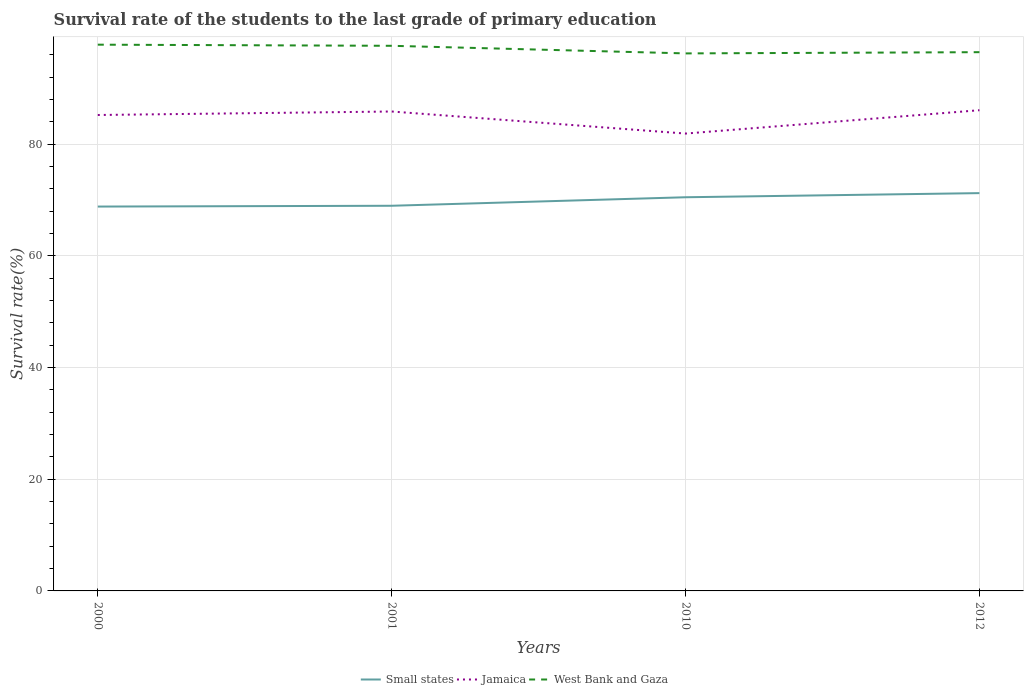Does the line corresponding to Jamaica intersect with the line corresponding to West Bank and Gaza?
Provide a short and direct response. No. Across all years, what is the maximum survival rate of the students in Jamaica?
Your answer should be very brief. 81.9. In which year was the survival rate of the students in West Bank and Gaza maximum?
Your answer should be compact. 2010. What is the total survival rate of the students in Small states in the graph?
Ensure brevity in your answer.  -2.41. What is the difference between the highest and the second highest survival rate of the students in Small states?
Provide a short and direct response. 2.41. Is the survival rate of the students in Small states strictly greater than the survival rate of the students in West Bank and Gaza over the years?
Provide a short and direct response. Yes. How many years are there in the graph?
Provide a short and direct response. 4. Does the graph contain any zero values?
Your response must be concise. No. Does the graph contain grids?
Give a very brief answer. Yes. Where does the legend appear in the graph?
Your answer should be very brief. Bottom center. How are the legend labels stacked?
Your answer should be very brief. Horizontal. What is the title of the graph?
Offer a terse response. Survival rate of the students to the last grade of primary education. What is the label or title of the X-axis?
Provide a short and direct response. Years. What is the label or title of the Y-axis?
Provide a succinct answer. Survival rate(%). What is the Survival rate(%) in Small states in 2000?
Your answer should be compact. 68.83. What is the Survival rate(%) in Jamaica in 2000?
Offer a terse response. 85.22. What is the Survival rate(%) in West Bank and Gaza in 2000?
Your answer should be compact. 97.82. What is the Survival rate(%) in Small states in 2001?
Make the answer very short. 68.97. What is the Survival rate(%) of Jamaica in 2001?
Offer a very short reply. 85.85. What is the Survival rate(%) of West Bank and Gaza in 2001?
Ensure brevity in your answer.  97.61. What is the Survival rate(%) of Small states in 2010?
Your response must be concise. 70.49. What is the Survival rate(%) in Jamaica in 2010?
Provide a succinct answer. 81.9. What is the Survival rate(%) of West Bank and Gaza in 2010?
Give a very brief answer. 96.25. What is the Survival rate(%) of Small states in 2012?
Your answer should be very brief. 71.23. What is the Survival rate(%) of Jamaica in 2012?
Provide a short and direct response. 86.08. What is the Survival rate(%) in West Bank and Gaza in 2012?
Make the answer very short. 96.47. Across all years, what is the maximum Survival rate(%) of Small states?
Ensure brevity in your answer.  71.23. Across all years, what is the maximum Survival rate(%) of Jamaica?
Keep it short and to the point. 86.08. Across all years, what is the maximum Survival rate(%) in West Bank and Gaza?
Your answer should be compact. 97.82. Across all years, what is the minimum Survival rate(%) in Small states?
Your response must be concise. 68.83. Across all years, what is the minimum Survival rate(%) in Jamaica?
Make the answer very short. 81.9. Across all years, what is the minimum Survival rate(%) of West Bank and Gaza?
Ensure brevity in your answer.  96.25. What is the total Survival rate(%) of Small states in the graph?
Offer a very short reply. 279.52. What is the total Survival rate(%) in Jamaica in the graph?
Provide a short and direct response. 339.05. What is the total Survival rate(%) in West Bank and Gaza in the graph?
Ensure brevity in your answer.  388.16. What is the difference between the Survival rate(%) of Small states in 2000 and that in 2001?
Offer a very short reply. -0.14. What is the difference between the Survival rate(%) in Jamaica in 2000 and that in 2001?
Your answer should be very brief. -0.63. What is the difference between the Survival rate(%) of West Bank and Gaza in 2000 and that in 2001?
Offer a terse response. 0.2. What is the difference between the Survival rate(%) of Small states in 2000 and that in 2010?
Provide a succinct answer. -1.67. What is the difference between the Survival rate(%) in Jamaica in 2000 and that in 2010?
Make the answer very short. 3.32. What is the difference between the Survival rate(%) in West Bank and Gaza in 2000 and that in 2010?
Your answer should be compact. 1.56. What is the difference between the Survival rate(%) in Small states in 2000 and that in 2012?
Offer a terse response. -2.41. What is the difference between the Survival rate(%) of Jamaica in 2000 and that in 2012?
Make the answer very short. -0.86. What is the difference between the Survival rate(%) in West Bank and Gaza in 2000 and that in 2012?
Your answer should be very brief. 1.34. What is the difference between the Survival rate(%) of Small states in 2001 and that in 2010?
Offer a terse response. -1.52. What is the difference between the Survival rate(%) of Jamaica in 2001 and that in 2010?
Ensure brevity in your answer.  3.95. What is the difference between the Survival rate(%) in West Bank and Gaza in 2001 and that in 2010?
Provide a short and direct response. 1.36. What is the difference between the Survival rate(%) in Small states in 2001 and that in 2012?
Your response must be concise. -2.26. What is the difference between the Survival rate(%) in Jamaica in 2001 and that in 2012?
Provide a succinct answer. -0.23. What is the difference between the Survival rate(%) in West Bank and Gaza in 2001 and that in 2012?
Give a very brief answer. 1.14. What is the difference between the Survival rate(%) in Small states in 2010 and that in 2012?
Ensure brevity in your answer.  -0.74. What is the difference between the Survival rate(%) of Jamaica in 2010 and that in 2012?
Offer a terse response. -4.18. What is the difference between the Survival rate(%) of West Bank and Gaza in 2010 and that in 2012?
Your answer should be compact. -0.22. What is the difference between the Survival rate(%) in Small states in 2000 and the Survival rate(%) in Jamaica in 2001?
Provide a succinct answer. -17.02. What is the difference between the Survival rate(%) of Small states in 2000 and the Survival rate(%) of West Bank and Gaza in 2001?
Give a very brief answer. -28.79. What is the difference between the Survival rate(%) in Jamaica in 2000 and the Survival rate(%) in West Bank and Gaza in 2001?
Offer a very short reply. -12.39. What is the difference between the Survival rate(%) in Small states in 2000 and the Survival rate(%) in Jamaica in 2010?
Provide a short and direct response. -13.07. What is the difference between the Survival rate(%) in Small states in 2000 and the Survival rate(%) in West Bank and Gaza in 2010?
Your response must be concise. -27.43. What is the difference between the Survival rate(%) of Jamaica in 2000 and the Survival rate(%) of West Bank and Gaza in 2010?
Provide a succinct answer. -11.03. What is the difference between the Survival rate(%) of Small states in 2000 and the Survival rate(%) of Jamaica in 2012?
Provide a succinct answer. -17.25. What is the difference between the Survival rate(%) in Small states in 2000 and the Survival rate(%) in West Bank and Gaza in 2012?
Give a very brief answer. -27.65. What is the difference between the Survival rate(%) in Jamaica in 2000 and the Survival rate(%) in West Bank and Gaza in 2012?
Give a very brief answer. -11.25. What is the difference between the Survival rate(%) of Small states in 2001 and the Survival rate(%) of Jamaica in 2010?
Make the answer very short. -12.93. What is the difference between the Survival rate(%) of Small states in 2001 and the Survival rate(%) of West Bank and Gaza in 2010?
Your answer should be compact. -27.28. What is the difference between the Survival rate(%) of Jamaica in 2001 and the Survival rate(%) of West Bank and Gaza in 2010?
Make the answer very short. -10.4. What is the difference between the Survival rate(%) of Small states in 2001 and the Survival rate(%) of Jamaica in 2012?
Offer a very short reply. -17.11. What is the difference between the Survival rate(%) of Small states in 2001 and the Survival rate(%) of West Bank and Gaza in 2012?
Offer a terse response. -27.5. What is the difference between the Survival rate(%) in Jamaica in 2001 and the Survival rate(%) in West Bank and Gaza in 2012?
Ensure brevity in your answer.  -10.62. What is the difference between the Survival rate(%) of Small states in 2010 and the Survival rate(%) of Jamaica in 2012?
Your answer should be very brief. -15.59. What is the difference between the Survival rate(%) of Small states in 2010 and the Survival rate(%) of West Bank and Gaza in 2012?
Ensure brevity in your answer.  -25.98. What is the difference between the Survival rate(%) of Jamaica in 2010 and the Survival rate(%) of West Bank and Gaza in 2012?
Provide a succinct answer. -14.57. What is the average Survival rate(%) of Small states per year?
Ensure brevity in your answer.  69.88. What is the average Survival rate(%) of Jamaica per year?
Keep it short and to the point. 84.76. What is the average Survival rate(%) in West Bank and Gaza per year?
Provide a succinct answer. 97.04. In the year 2000, what is the difference between the Survival rate(%) in Small states and Survival rate(%) in Jamaica?
Provide a succinct answer. -16.4. In the year 2000, what is the difference between the Survival rate(%) in Small states and Survival rate(%) in West Bank and Gaza?
Ensure brevity in your answer.  -28.99. In the year 2000, what is the difference between the Survival rate(%) in Jamaica and Survival rate(%) in West Bank and Gaza?
Make the answer very short. -12.59. In the year 2001, what is the difference between the Survival rate(%) of Small states and Survival rate(%) of Jamaica?
Provide a succinct answer. -16.88. In the year 2001, what is the difference between the Survival rate(%) in Small states and Survival rate(%) in West Bank and Gaza?
Ensure brevity in your answer.  -28.64. In the year 2001, what is the difference between the Survival rate(%) in Jamaica and Survival rate(%) in West Bank and Gaza?
Ensure brevity in your answer.  -11.77. In the year 2010, what is the difference between the Survival rate(%) of Small states and Survival rate(%) of Jamaica?
Offer a terse response. -11.41. In the year 2010, what is the difference between the Survival rate(%) in Small states and Survival rate(%) in West Bank and Gaza?
Your answer should be very brief. -25.76. In the year 2010, what is the difference between the Survival rate(%) of Jamaica and Survival rate(%) of West Bank and Gaza?
Your answer should be very brief. -14.35. In the year 2012, what is the difference between the Survival rate(%) in Small states and Survival rate(%) in Jamaica?
Keep it short and to the point. -14.85. In the year 2012, what is the difference between the Survival rate(%) in Small states and Survival rate(%) in West Bank and Gaza?
Your answer should be very brief. -25.24. In the year 2012, what is the difference between the Survival rate(%) of Jamaica and Survival rate(%) of West Bank and Gaza?
Your answer should be compact. -10.39. What is the ratio of the Survival rate(%) in Small states in 2000 to that in 2001?
Provide a short and direct response. 1. What is the ratio of the Survival rate(%) in Jamaica in 2000 to that in 2001?
Provide a short and direct response. 0.99. What is the ratio of the Survival rate(%) of West Bank and Gaza in 2000 to that in 2001?
Offer a terse response. 1. What is the ratio of the Survival rate(%) of Small states in 2000 to that in 2010?
Give a very brief answer. 0.98. What is the ratio of the Survival rate(%) of Jamaica in 2000 to that in 2010?
Make the answer very short. 1.04. What is the ratio of the Survival rate(%) in West Bank and Gaza in 2000 to that in 2010?
Give a very brief answer. 1.02. What is the ratio of the Survival rate(%) of Small states in 2000 to that in 2012?
Provide a succinct answer. 0.97. What is the ratio of the Survival rate(%) in West Bank and Gaza in 2000 to that in 2012?
Offer a very short reply. 1.01. What is the ratio of the Survival rate(%) in Small states in 2001 to that in 2010?
Offer a terse response. 0.98. What is the ratio of the Survival rate(%) in Jamaica in 2001 to that in 2010?
Make the answer very short. 1.05. What is the ratio of the Survival rate(%) of West Bank and Gaza in 2001 to that in 2010?
Offer a very short reply. 1.01. What is the ratio of the Survival rate(%) in Small states in 2001 to that in 2012?
Provide a short and direct response. 0.97. What is the ratio of the Survival rate(%) in West Bank and Gaza in 2001 to that in 2012?
Provide a short and direct response. 1.01. What is the ratio of the Survival rate(%) of Small states in 2010 to that in 2012?
Provide a short and direct response. 0.99. What is the ratio of the Survival rate(%) of Jamaica in 2010 to that in 2012?
Make the answer very short. 0.95. What is the ratio of the Survival rate(%) of West Bank and Gaza in 2010 to that in 2012?
Your answer should be very brief. 1. What is the difference between the highest and the second highest Survival rate(%) in Small states?
Your response must be concise. 0.74. What is the difference between the highest and the second highest Survival rate(%) in Jamaica?
Provide a short and direct response. 0.23. What is the difference between the highest and the second highest Survival rate(%) in West Bank and Gaza?
Offer a very short reply. 0.2. What is the difference between the highest and the lowest Survival rate(%) of Small states?
Give a very brief answer. 2.41. What is the difference between the highest and the lowest Survival rate(%) in Jamaica?
Ensure brevity in your answer.  4.18. What is the difference between the highest and the lowest Survival rate(%) of West Bank and Gaza?
Offer a very short reply. 1.56. 